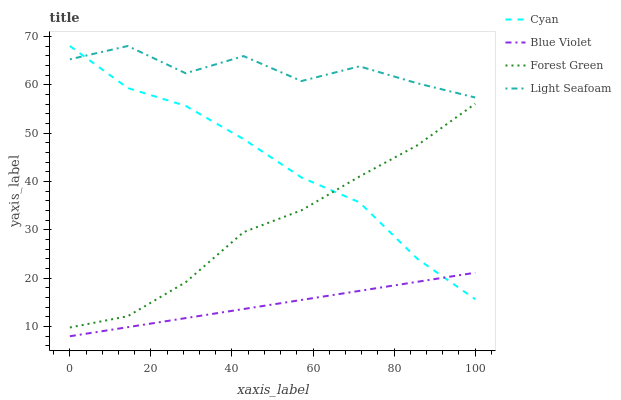Does Blue Violet have the minimum area under the curve?
Answer yes or no. Yes. Does Light Seafoam have the maximum area under the curve?
Answer yes or no. Yes. Does Forest Green have the minimum area under the curve?
Answer yes or no. No. Does Forest Green have the maximum area under the curve?
Answer yes or no. No. Is Blue Violet the smoothest?
Answer yes or no. Yes. Is Light Seafoam the roughest?
Answer yes or no. Yes. Is Forest Green the smoothest?
Answer yes or no. No. Is Forest Green the roughest?
Answer yes or no. No. Does Blue Violet have the lowest value?
Answer yes or no. Yes. Does Forest Green have the lowest value?
Answer yes or no. No. Does Light Seafoam have the highest value?
Answer yes or no. Yes. Does Forest Green have the highest value?
Answer yes or no. No. Is Forest Green less than Light Seafoam?
Answer yes or no. Yes. Is Forest Green greater than Blue Violet?
Answer yes or no. Yes. Does Blue Violet intersect Cyan?
Answer yes or no. Yes. Is Blue Violet less than Cyan?
Answer yes or no. No. Is Blue Violet greater than Cyan?
Answer yes or no. No. Does Forest Green intersect Light Seafoam?
Answer yes or no. No. 